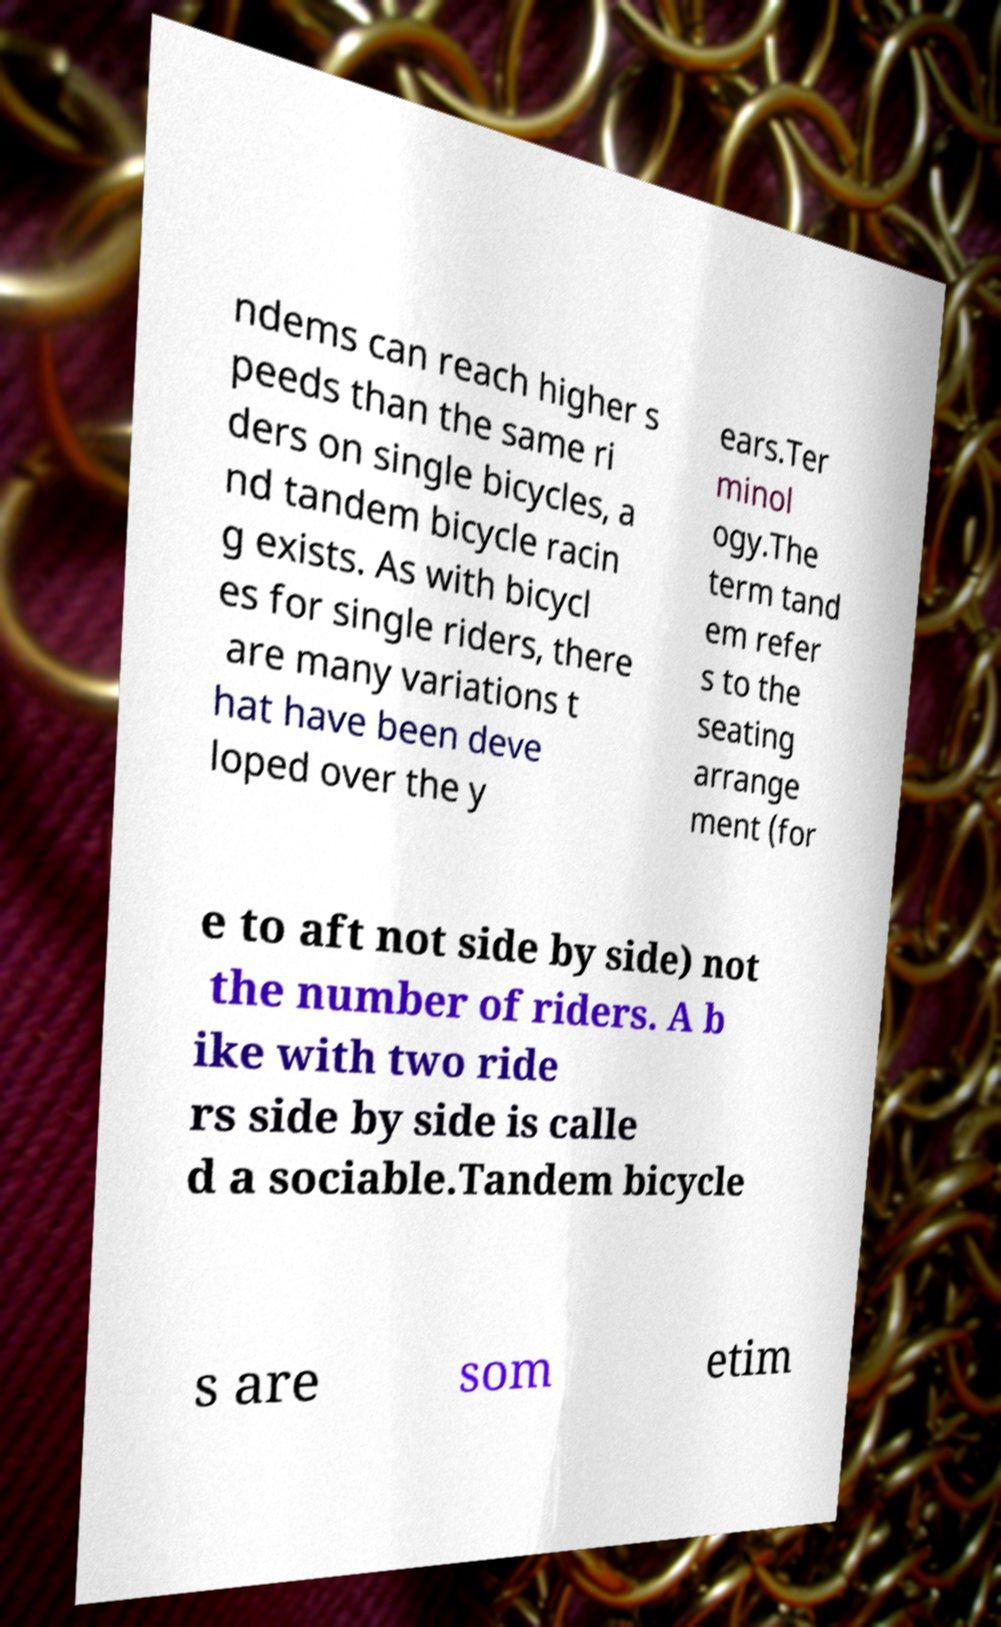Could you extract and type out the text from this image? ndems can reach higher s peeds than the same ri ders on single bicycles, a nd tandem bicycle racin g exists. As with bicycl es for single riders, there are many variations t hat have been deve loped over the y ears.Ter minol ogy.The term tand em refer s to the seating arrange ment (for e to aft not side by side) not the number of riders. A b ike with two ride rs side by side is calle d a sociable.Tandem bicycle s are som etim 